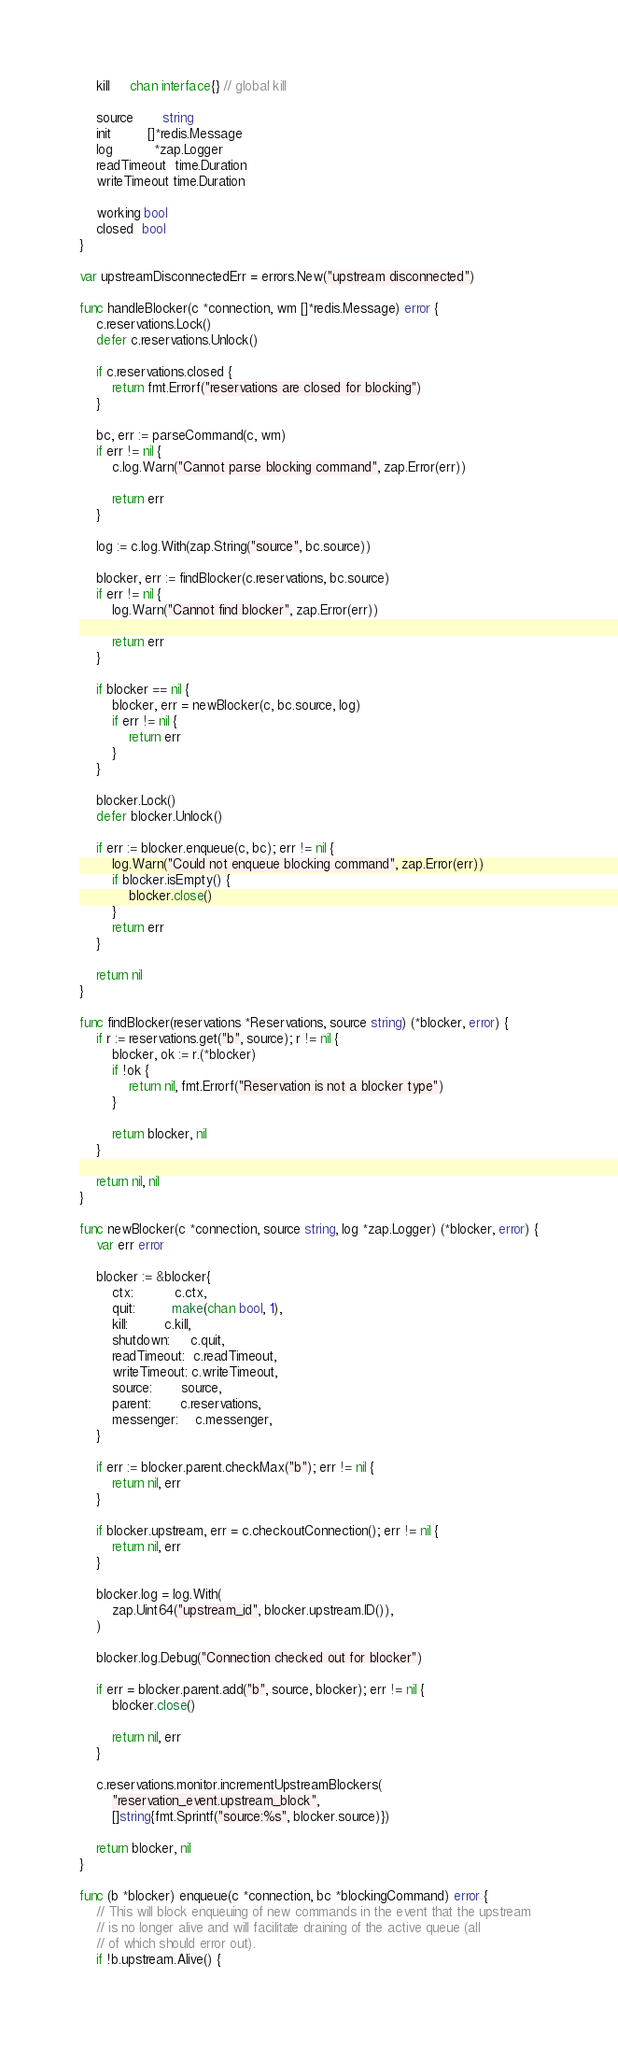<code> <loc_0><loc_0><loc_500><loc_500><_Go_>	kill     chan interface{} // global kill

	source       string
	init         []*redis.Message
	log          *zap.Logger
	readTimeout  time.Duration
	writeTimeout time.Duration

	working bool
	closed  bool
}

var upstreamDisconnectedErr = errors.New("upstream disconnected")

func handleBlocker(c *connection, wm []*redis.Message) error {
	c.reservations.Lock()
	defer c.reservations.Unlock()

	if c.reservations.closed {
		return fmt.Errorf("reservations are closed for blocking")
	}

	bc, err := parseCommand(c, wm)
	if err != nil {
		c.log.Warn("Cannot parse blocking command", zap.Error(err))

		return err
	}

	log := c.log.With(zap.String("source", bc.source))

	blocker, err := findBlocker(c.reservations, bc.source)
	if err != nil {
		log.Warn("Cannot find blocker", zap.Error(err))

		return err
	}

	if blocker == nil {
		blocker, err = newBlocker(c, bc.source, log)
		if err != nil {
			return err
		}
	}

	blocker.Lock()
	defer blocker.Unlock()

	if err := blocker.enqueue(c, bc); err != nil {
		log.Warn("Could not enqueue blocking command", zap.Error(err))
		if blocker.isEmpty() {
			blocker.close()
		}
		return err
	}

	return nil
}

func findBlocker(reservations *Reservations, source string) (*blocker, error) {
	if r := reservations.get("b", source); r != nil {
		blocker, ok := r.(*blocker)
		if !ok {
			return nil, fmt.Errorf("Reservation is not a blocker type")
		}

		return blocker, nil
	}

	return nil, nil
}

func newBlocker(c *connection, source string, log *zap.Logger) (*blocker, error) {
	var err error

	blocker := &blocker{
		ctx:          c.ctx,
		quit:         make(chan bool, 1),
		kill:         c.kill,
		shutdown:     c.quit,
		readTimeout:  c.readTimeout,
		writeTimeout: c.writeTimeout,
		source:       source,
		parent:       c.reservations,
		messenger:    c.messenger,
	}

	if err := blocker.parent.checkMax("b"); err != nil {
		return nil, err
	}

	if blocker.upstream, err = c.checkoutConnection(); err != nil {
		return nil, err
	}

	blocker.log = log.With(
		zap.Uint64("upstream_id", blocker.upstream.ID()),
	)

	blocker.log.Debug("Connection checked out for blocker")

	if err = blocker.parent.add("b", source, blocker); err != nil {
		blocker.close()

		return nil, err
	}

	c.reservations.monitor.incrementUpstreamBlockers(
		"reservation_event.upstream_block",
		[]string{fmt.Sprintf("source:%s", blocker.source)})

	return blocker, nil
}

func (b *blocker) enqueue(c *connection, bc *blockingCommand) error {
	// This will block enqueuing of new commands in the event that the upstream
	// is no longer alive and will facilitate draining of the active queue (all
	// of which should error out).
	if !b.upstream.Alive() {</code> 